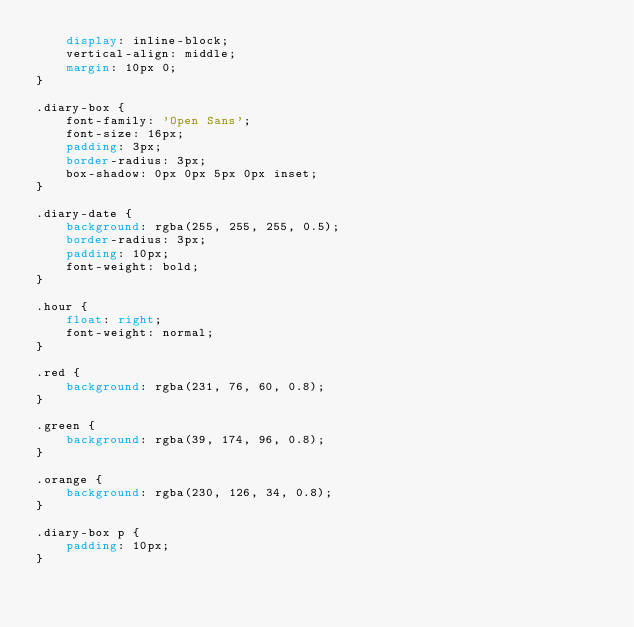Convert code to text. <code><loc_0><loc_0><loc_500><loc_500><_CSS_>    display: inline-block;
    vertical-align: middle;
    margin: 10px 0;
}

.diary-box {
    font-family: 'Open Sans';
    font-size: 16px;
    padding: 3px;
    border-radius: 3px;
    box-shadow: 0px 0px 5px 0px inset;
}

.diary-date {
    background: rgba(255, 255, 255, 0.5);
    border-radius: 3px;
    padding: 10px;
    font-weight: bold;
}

.hour {
    float: right;
    font-weight: normal;
}

.red {
    background: rgba(231, 76, 60, 0.8);
}

.green {
    background: rgba(39, 174, 96, 0.8);
}

.orange {
    background: rgba(230, 126, 34, 0.8);
}

.diary-box p {
    padding: 10px;
}</code> 